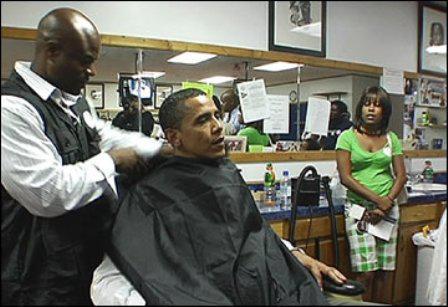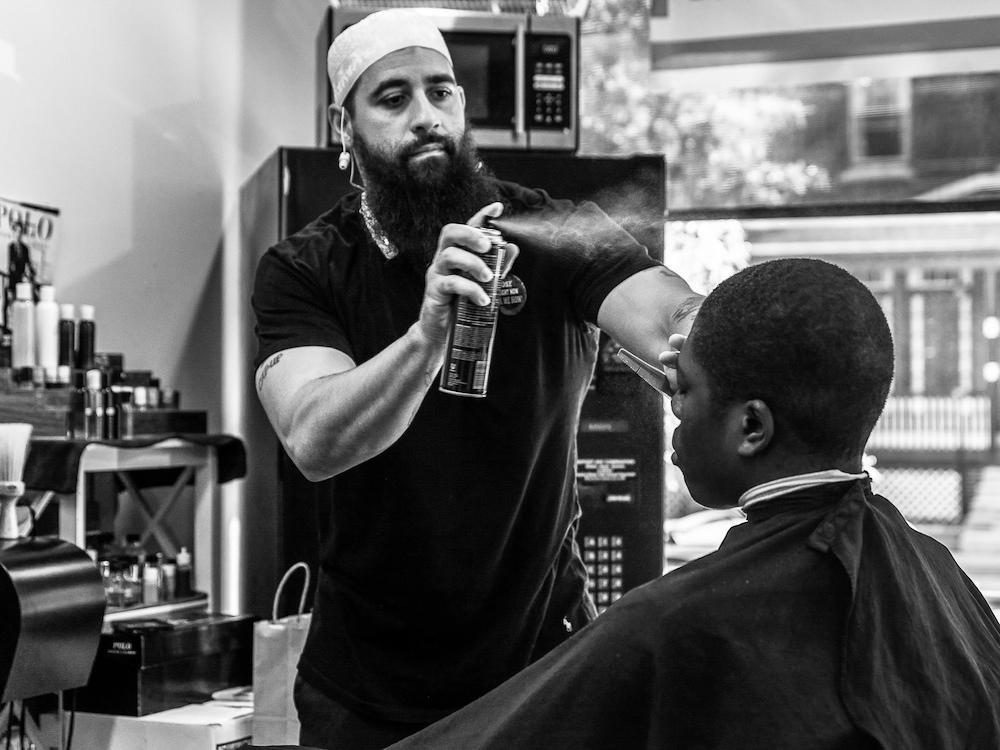The first image is the image on the left, the second image is the image on the right. Analyze the images presented: Is the assertion "In each image, there is more than one person sitting down." valid? Answer yes or no. No. The first image is the image on the left, the second image is the image on the right. Evaluate the accuracy of this statement regarding the images: "the picture i=on the left is in color". Is it true? Answer yes or no. Yes. 